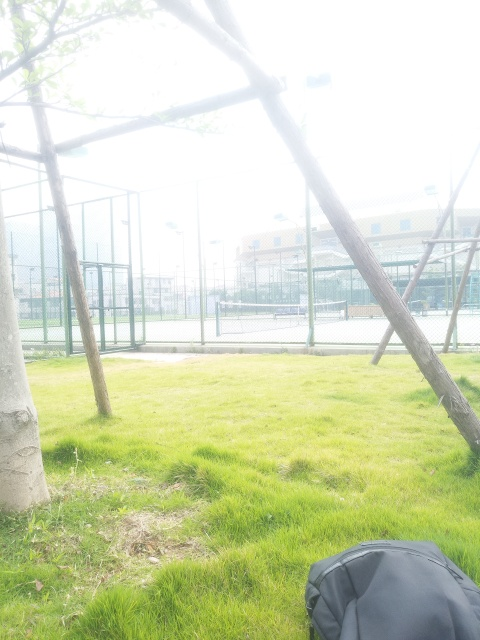What activities do you think are popular in this area? Given the setup of the site, activities such as tennis, basketball, and perhaps soccer could be popular here, as suggested by the enclosed courts. Additionally, the open grassy area is ideal for picnics, casual sports, or simply relaxing in the park, enjoying the outdoor environment. 